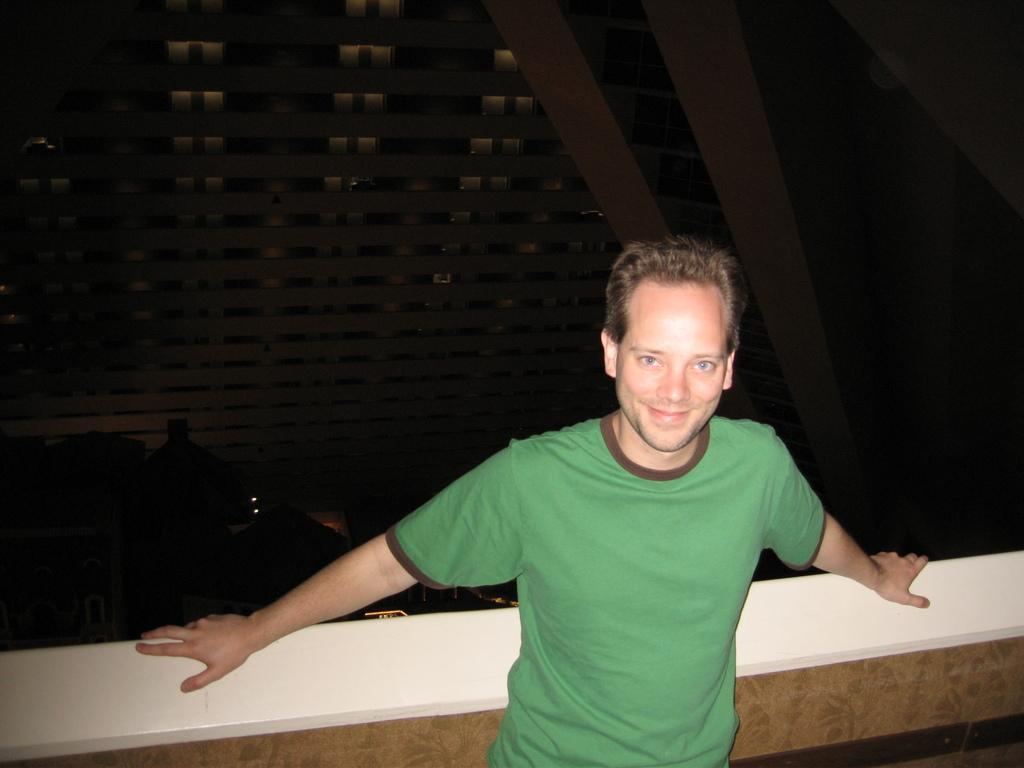Who or what is present in the image? There is a person in the image. Can you describe the person's position in relation to the wall? The person is standing in front of a wall. What can be seen behind the wall? There is a building behind the wall. What type of flame can be seen on the person's head in the image? There is no flame present on the person's head in the image. How many women are visible in the image? The image only features one person, and there is no indication of their gender, so it cannot be determined if they are a woman or not. 